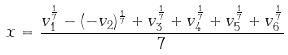<formula> <loc_0><loc_0><loc_500><loc_500>x = \frac { v _ { 1 } ^ { \frac { 1 } { 7 } } - ( - v _ { 2 } ) ^ { \frac { 1 } { 7 } } + v _ { 3 } ^ { \frac { 1 } { 7 } } + v _ { 4 } ^ { \frac { 1 } { 7 } } + v _ { 5 } ^ { \frac { 1 } { 7 } } + v _ { 6 } ^ { \frac { 1 } { 7 } } } { 7 }</formula> 